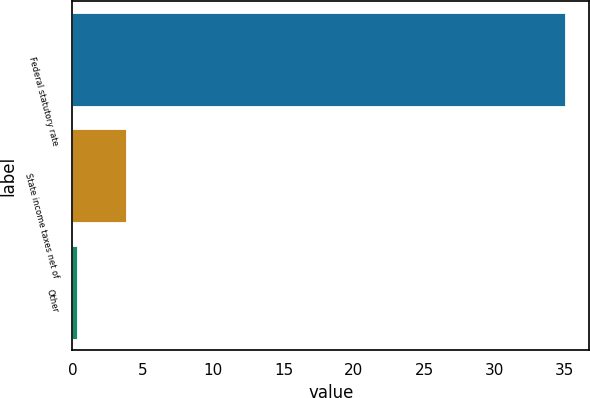Convert chart. <chart><loc_0><loc_0><loc_500><loc_500><bar_chart><fcel>Federal statutory rate<fcel>State income taxes net of<fcel>Other<nl><fcel>35<fcel>3.77<fcel>0.3<nl></chart> 